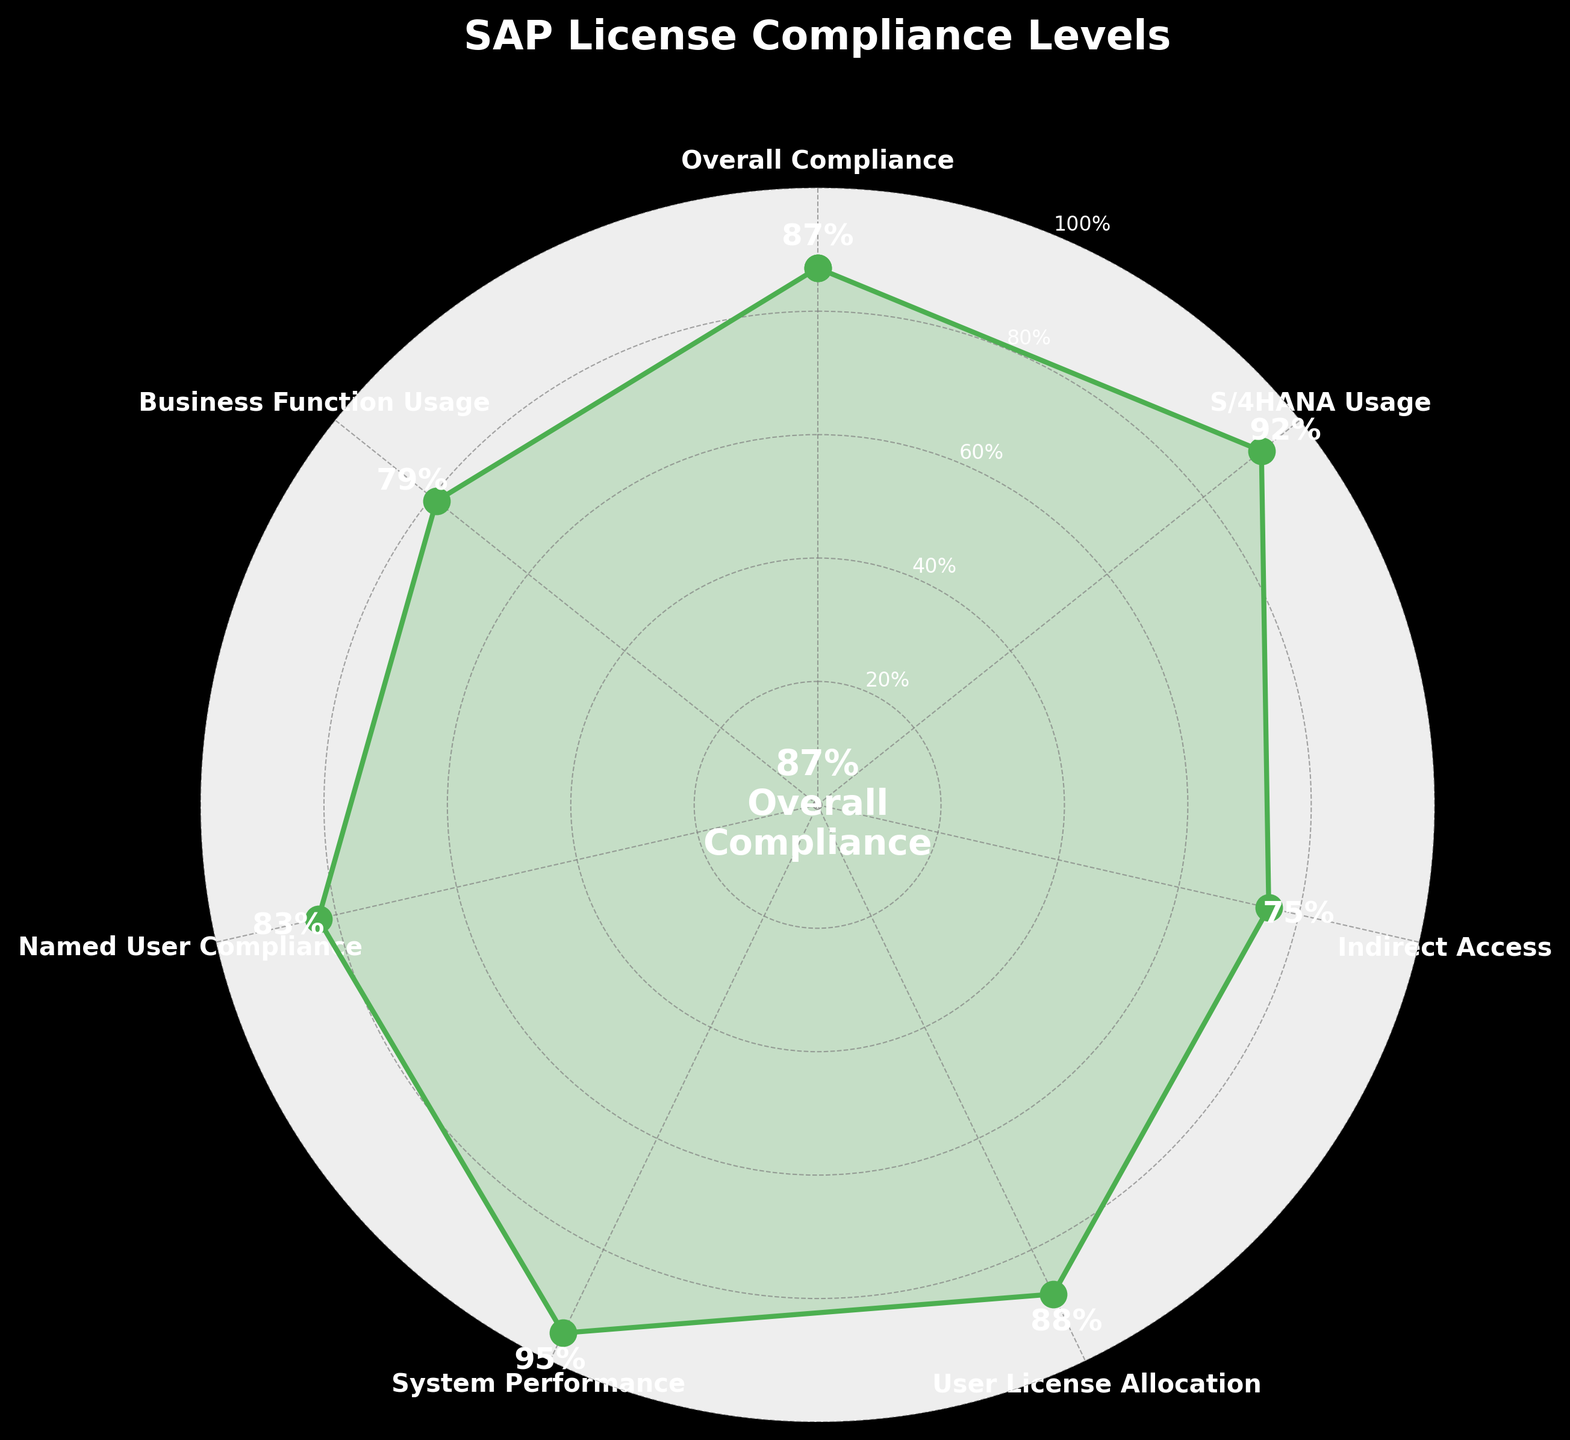What's the title of the chart? The title is usually displayed at the top of the chart. Looking at the chart, the title written is "SAP License Compliance Levels".
Answer: SAP License Compliance Levels What color is used to represent the data points? Data points are usually represented using a distinct color. In this chart, the data points are shown in green.
Answer: Green How many categories are displayed in the chart? The number of categories in the chart corresponds to the labels along the circumference. By counting these labels, we can determine that there are seven categories.
Answer: Seven What's the percentage value for the 'System Performance' category? Each category has a labeled percentage value. For 'System Performance,' the value is labeled next to it. The 'System Performance' category has a percentage value of 95%.
Answer: 95% Which category has the lowest compliance value? By comparing the percentage values of all categories, we can see that the 'Indirect Access' category has the lowest value of 75%.
Answer: Indirect Access What's the difference between 'S/4HANA Usage' and 'Business Function Usage' percentages? To find the difference, subtract the value of 'Business Function Usage' (79) from 'S/4HANA Usage' (92). 92 - 79 = 13. Therefore, the difference is 13%.
Answer: 13% What is the average compliance value of all categories? To find the average, add all the values together and divide by the number of categories: (87 + 92 + 75 + 88 + 95 + 83 + 79) / 7 = 84.14. The average compliance value is approximately 84.1%.
Answer: 84.1% Is the 'Named User Compliance' value higher than the 'Overall Compliance' value? 'Overall Compliance' has a value of 87%, and 'Named User Compliance' has a value of 83%. Since 83% is less than 87%, 'Named User Compliance' is not higher than 'Overall Compliance'.
Answer: No Which category has the highest compliance value? By comparing all the percentage values, we can see that 'System Performance' has the highest value of 95%.
Answer: System Performance What’s the overall compliance level shown at the center of the gauge? The overall compliance level is prominently displayed at the center of the gauge in the chart. It’s indicated as 87%.
Answer: 87% 